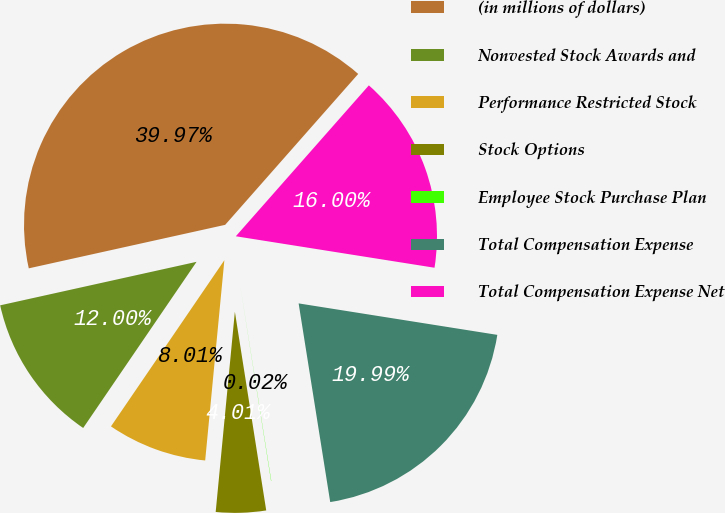Convert chart to OTSL. <chart><loc_0><loc_0><loc_500><loc_500><pie_chart><fcel>(in millions of dollars)<fcel>Nonvested Stock Awards and<fcel>Performance Restricted Stock<fcel>Stock Options<fcel>Employee Stock Purchase Plan<fcel>Total Compensation Expense<fcel>Total Compensation Expense Net<nl><fcel>39.97%<fcel>12.0%<fcel>8.01%<fcel>4.01%<fcel>0.02%<fcel>19.99%<fcel>16.0%<nl></chart> 